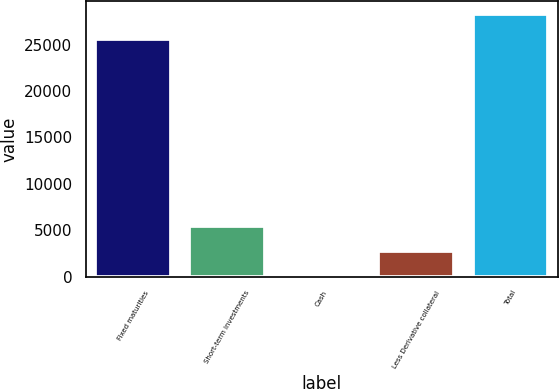Convert chart to OTSL. <chart><loc_0><loc_0><loc_500><loc_500><bar_chart><fcel>Fixed maturities<fcel>Short-term investments<fcel>Cash<fcel>Less Derivative collateral<fcel>Total<nl><fcel>25610<fcel>5423.6<fcel>119<fcel>2771.3<fcel>28262.3<nl></chart> 